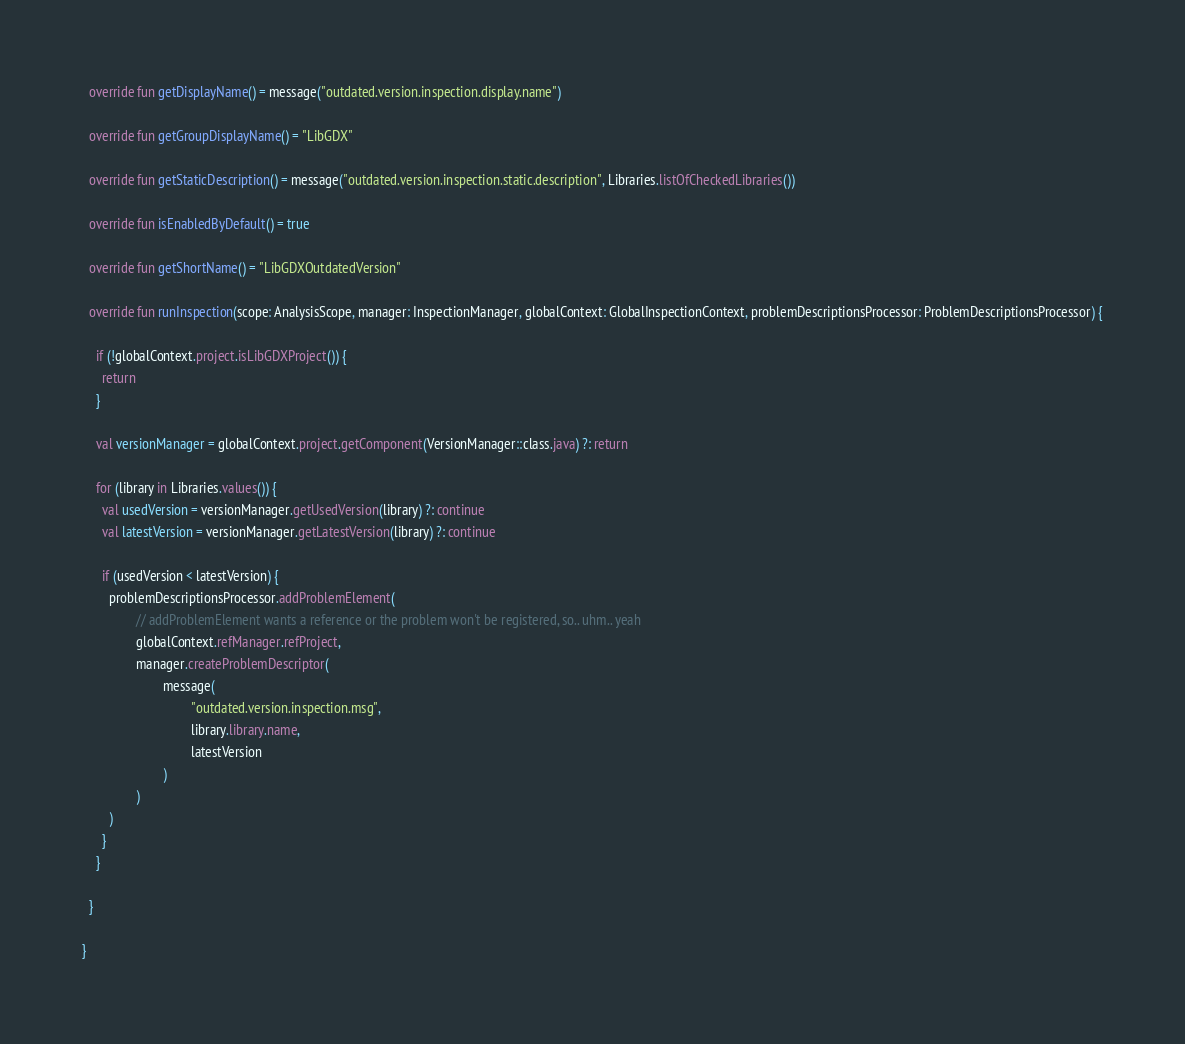Convert code to text. <code><loc_0><loc_0><loc_500><loc_500><_Kotlin_>
  override fun getDisplayName() = message("outdated.version.inspection.display.name")

  override fun getGroupDisplayName() = "LibGDX"

  override fun getStaticDescription() = message("outdated.version.inspection.static.description", Libraries.listOfCheckedLibraries())

  override fun isEnabledByDefault() = true

  override fun getShortName() = "LibGDXOutdatedVersion"

  override fun runInspection(scope: AnalysisScope, manager: InspectionManager, globalContext: GlobalInspectionContext, problemDescriptionsProcessor: ProblemDescriptionsProcessor) {

    if (!globalContext.project.isLibGDXProject()) {
      return
    }

    val versionManager = globalContext.project.getComponent(VersionManager::class.java) ?: return

    for (library in Libraries.values()) {
      val usedVersion = versionManager.getUsedVersion(library) ?: continue
      val latestVersion = versionManager.getLatestVersion(library) ?: continue

      if (usedVersion < latestVersion) {
        problemDescriptionsProcessor.addProblemElement(
                // addProblemElement wants a reference or the problem won't be registered, so.. uhm.. yeah
                globalContext.refManager.refProject,
                manager.createProblemDescriptor(
                        message(
                                "outdated.version.inspection.msg",
                                library.library.name,
                                latestVersion
                        )
                )
        )
      }
    }

  }

}</code> 